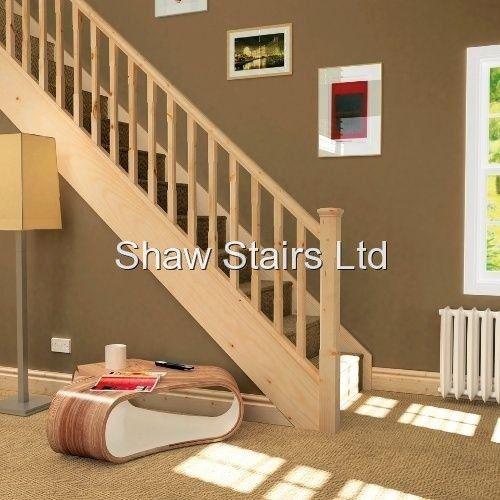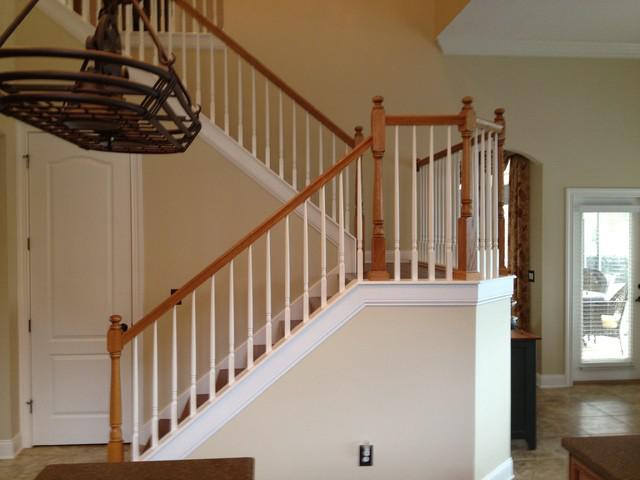The first image is the image on the left, the second image is the image on the right. Considering the images on both sides, is "In at least one image there is  white and light brown stair with a light brown rail and painted white poles." valid? Answer yes or no. Yes. The first image is the image on the left, the second image is the image on the right. Analyze the images presented: Is the assertion "The left image shows a staircase with a closed-in bottom and the edges of the stairs visible from the side, and the staircase ascends to the right, then turns leftward." valid? Answer yes or no. No. 